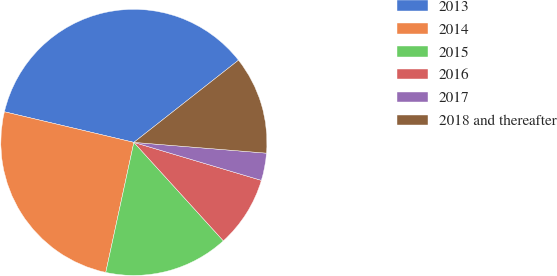Convert chart. <chart><loc_0><loc_0><loc_500><loc_500><pie_chart><fcel>2013<fcel>2014<fcel>2015<fcel>2016<fcel>2017<fcel>2018 and thereafter<nl><fcel>35.71%<fcel>25.31%<fcel>15.13%<fcel>8.65%<fcel>3.32%<fcel>11.89%<nl></chart> 